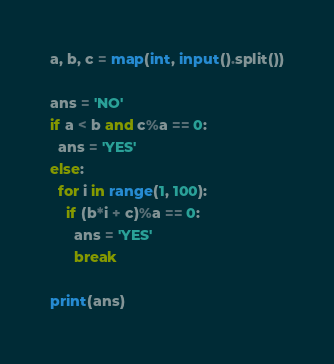Convert code to text. <code><loc_0><loc_0><loc_500><loc_500><_Python_>a, b, c = map(int, input().split())

ans = 'NO'
if a < b and c%a == 0:
  ans = 'YES'
else:
  for i in range(1, 100):
    if (b*i + c)%a == 0:
      ans = 'YES'
      break
  
print(ans)</code> 